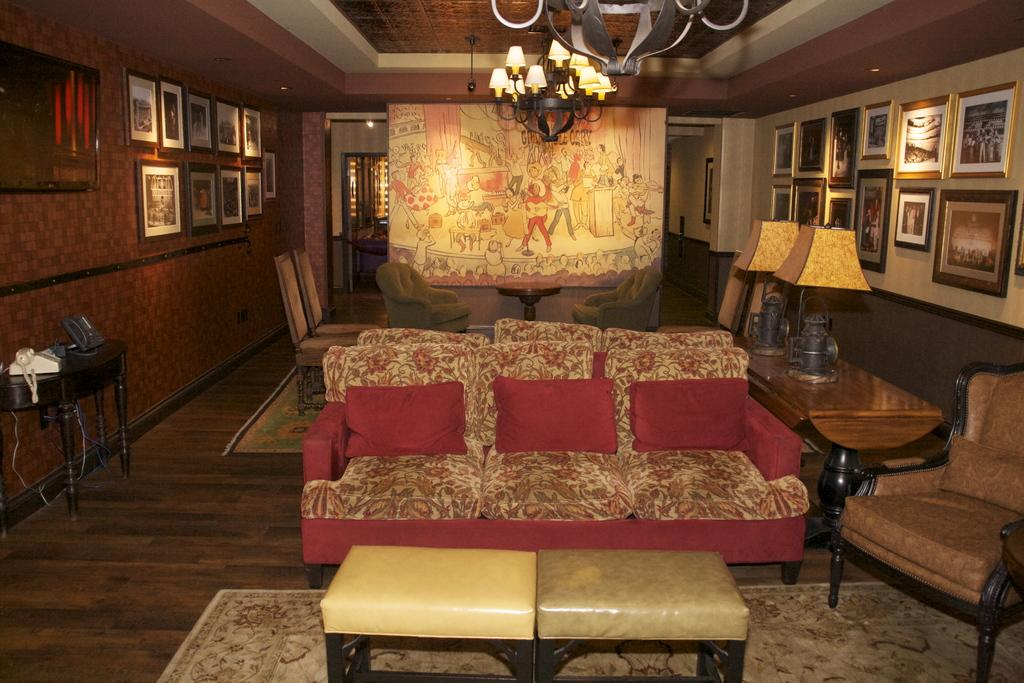What type of furniture is visible in the image? There is a sofa set, chairs, and a table in the image. What is on the table in the image? Lamps and lights are present on the table in the image. What can be seen on the wall in the image? There are photo frames on the wall. What day of the week is depicted in the image? There is no day of the week depicted in the image; it is a still a static picture. 